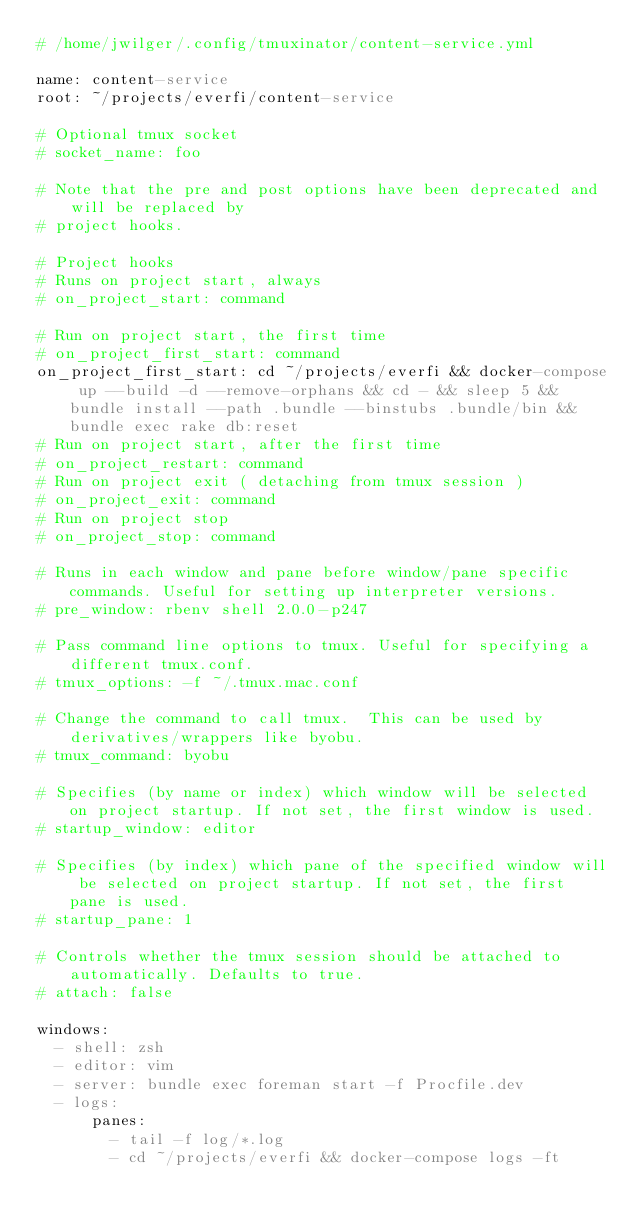Convert code to text. <code><loc_0><loc_0><loc_500><loc_500><_YAML_># /home/jwilger/.config/tmuxinator/content-service.yml

name: content-service
root: ~/projects/everfi/content-service

# Optional tmux socket
# socket_name: foo

# Note that the pre and post options have been deprecated and will be replaced by
# project hooks.

# Project hooks
# Runs on project start, always
# on_project_start: command

# Run on project start, the first time
# on_project_first_start: command
on_project_first_start: cd ~/projects/everfi && docker-compose up --build -d --remove-orphans && cd - && sleep 5 && bundle install --path .bundle --binstubs .bundle/bin && bundle exec rake db:reset
# Run on project start, after the first time
# on_project_restart: command
# Run on project exit ( detaching from tmux session )
# on_project_exit: command
# Run on project stop
# on_project_stop: command

# Runs in each window and pane before window/pane specific commands. Useful for setting up interpreter versions.
# pre_window: rbenv shell 2.0.0-p247

# Pass command line options to tmux. Useful for specifying a different tmux.conf.
# tmux_options: -f ~/.tmux.mac.conf

# Change the command to call tmux.  This can be used by derivatives/wrappers like byobu.
# tmux_command: byobu

# Specifies (by name or index) which window will be selected on project startup. If not set, the first window is used.
# startup_window: editor

# Specifies (by index) which pane of the specified window will be selected on project startup. If not set, the first pane is used.
# startup_pane: 1

# Controls whether the tmux session should be attached to automatically. Defaults to true.
# attach: false

windows:
  - shell: zsh
  - editor: vim
  - server: bundle exec foreman start -f Procfile.dev
  - logs:
      panes:
        - tail -f log/*.log
        - cd ~/projects/everfi && docker-compose logs -ft
</code> 